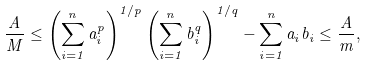Convert formula to latex. <formula><loc_0><loc_0><loc_500><loc_500>\frac { A } { M } \leq \left ( \sum _ { i = 1 } ^ { n } a _ { i } ^ { p } \right ) ^ { 1 / p } \left ( \sum _ { i = 1 } ^ { n } b _ { i } ^ { q } \right ) ^ { 1 / q } - \sum _ { i = 1 } ^ { n } a _ { i } b _ { i } \leq \frac { A } { m } ,</formula> 